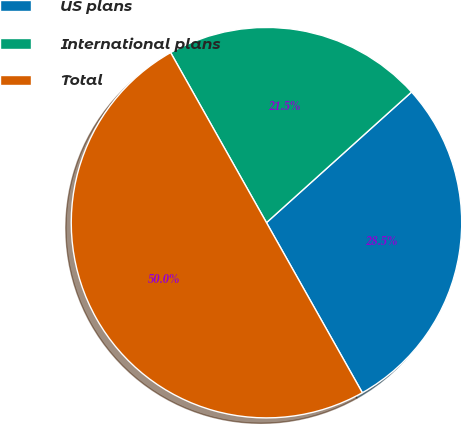Convert chart to OTSL. <chart><loc_0><loc_0><loc_500><loc_500><pie_chart><fcel>US plans<fcel>International plans<fcel>Total<nl><fcel>28.5%<fcel>21.5%<fcel>50.0%<nl></chart> 